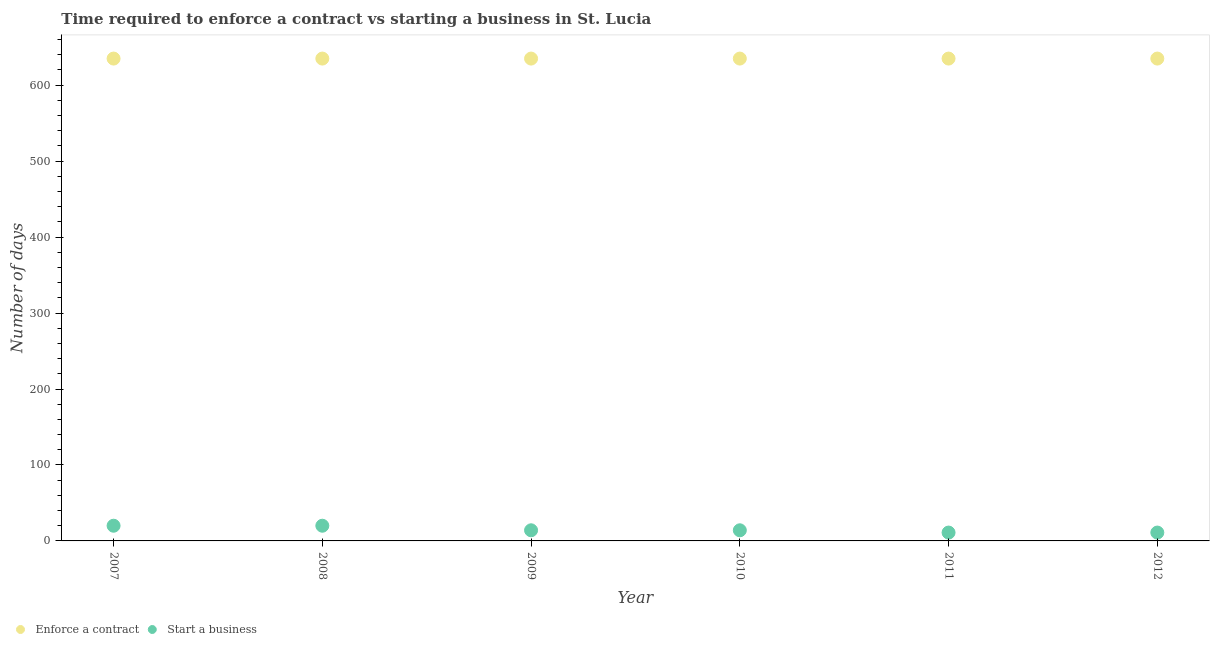How many different coloured dotlines are there?
Make the answer very short. 2. What is the number of days to enforece a contract in 2007?
Provide a succinct answer. 635. Across all years, what is the maximum number of days to start a business?
Ensure brevity in your answer.  20. Across all years, what is the minimum number of days to start a business?
Your answer should be compact. 11. In which year was the number of days to enforece a contract maximum?
Your answer should be compact. 2007. In which year was the number of days to start a business minimum?
Offer a terse response. 2011. What is the total number of days to enforece a contract in the graph?
Make the answer very short. 3810. What is the difference between the number of days to start a business in 2009 and that in 2010?
Offer a very short reply. 0. What is the difference between the number of days to enforece a contract in 2011 and the number of days to start a business in 2010?
Your answer should be compact. 621. What is the average number of days to enforece a contract per year?
Provide a short and direct response. 635. In the year 2009, what is the difference between the number of days to start a business and number of days to enforece a contract?
Provide a succinct answer. -621. In how many years, is the number of days to enforece a contract greater than 380 days?
Make the answer very short. 6. Is the difference between the number of days to start a business in 2010 and 2011 greater than the difference between the number of days to enforece a contract in 2010 and 2011?
Offer a very short reply. Yes. What is the difference between the highest and the lowest number of days to start a business?
Ensure brevity in your answer.  9. In how many years, is the number of days to enforece a contract greater than the average number of days to enforece a contract taken over all years?
Provide a succinct answer. 0. Is the number of days to enforece a contract strictly greater than the number of days to start a business over the years?
Your answer should be very brief. Yes. Is the number of days to start a business strictly less than the number of days to enforece a contract over the years?
Give a very brief answer. Yes. What is the difference between two consecutive major ticks on the Y-axis?
Ensure brevity in your answer.  100. Are the values on the major ticks of Y-axis written in scientific E-notation?
Ensure brevity in your answer.  No. How are the legend labels stacked?
Your response must be concise. Horizontal. What is the title of the graph?
Provide a short and direct response. Time required to enforce a contract vs starting a business in St. Lucia. What is the label or title of the X-axis?
Provide a succinct answer. Year. What is the label or title of the Y-axis?
Your response must be concise. Number of days. What is the Number of days of Enforce a contract in 2007?
Offer a terse response. 635. What is the Number of days in Start a business in 2007?
Your response must be concise. 20. What is the Number of days in Enforce a contract in 2008?
Your answer should be compact. 635. What is the Number of days in Start a business in 2008?
Provide a short and direct response. 20. What is the Number of days of Enforce a contract in 2009?
Offer a terse response. 635. What is the Number of days of Enforce a contract in 2010?
Ensure brevity in your answer.  635. What is the Number of days in Enforce a contract in 2011?
Keep it short and to the point. 635. What is the Number of days of Enforce a contract in 2012?
Offer a very short reply. 635. Across all years, what is the maximum Number of days in Enforce a contract?
Provide a short and direct response. 635. Across all years, what is the maximum Number of days of Start a business?
Give a very brief answer. 20. Across all years, what is the minimum Number of days of Enforce a contract?
Your answer should be compact. 635. What is the total Number of days in Enforce a contract in the graph?
Offer a very short reply. 3810. What is the difference between the Number of days of Enforce a contract in 2007 and that in 2008?
Keep it short and to the point. 0. What is the difference between the Number of days of Start a business in 2007 and that in 2008?
Your answer should be very brief. 0. What is the difference between the Number of days of Enforce a contract in 2007 and that in 2009?
Offer a terse response. 0. What is the difference between the Number of days of Start a business in 2007 and that in 2009?
Provide a succinct answer. 6. What is the difference between the Number of days in Enforce a contract in 2007 and that in 2012?
Offer a very short reply. 0. What is the difference between the Number of days of Start a business in 2007 and that in 2012?
Your response must be concise. 9. What is the difference between the Number of days in Enforce a contract in 2008 and that in 2009?
Give a very brief answer. 0. What is the difference between the Number of days in Enforce a contract in 2008 and that in 2010?
Your answer should be compact. 0. What is the difference between the Number of days in Start a business in 2008 and that in 2010?
Your answer should be compact. 6. What is the difference between the Number of days of Enforce a contract in 2008 and that in 2011?
Ensure brevity in your answer.  0. What is the difference between the Number of days of Start a business in 2008 and that in 2011?
Offer a terse response. 9. What is the difference between the Number of days of Enforce a contract in 2009 and that in 2010?
Offer a terse response. 0. What is the difference between the Number of days of Start a business in 2009 and that in 2011?
Your answer should be very brief. 3. What is the difference between the Number of days in Start a business in 2009 and that in 2012?
Keep it short and to the point. 3. What is the difference between the Number of days in Start a business in 2010 and that in 2012?
Your answer should be very brief. 3. What is the difference between the Number of days in Start a business in 2011 and that in 2012?
Your answer should be very brief. 0. What is the difference between the Number of days in Enforce a contract in 2007 and the Number of days in Start a business in 2008?
Your response must be concise. 615. What is the difference between the Number of days of Enforce a contract in 2007 and the Number of days of Start a business in 2009?
Keep it short and to the point. 621. What is the difference between the Number of days in Enforce a contract in 2007 and the Number of days in Start a business in 2010?
Offer a very short reply. 621. What is the difference between the Number of days in Enforce a contract in 2007 and the Number of days in Start a business in 2011?
Your response must be concise. 624. What is the difference between the Number of days in Enforce a contract in 2007 and the Number of days in Start a business in 2012?
Offer a terse response. 624. What is the difference between the Number of days of Enforce a contract in 2008 and the Number of days of Start a business in 2009?
Offer a very short reply. 621. What is the difference between the Number of days in Enforce a contract in 2008 and the Number of days in Start a business in 2010?
Offer a terse response. 621. What is the difference between the Number of days of Enforce a contract in 2008 and the Number of days of Start a business in 2011?
Give a very brief answer. 624. What is the difference between the Number of days in Enforce a contract in 2008 and the Number of days in Start a business in 2012?
Keep it short and to the point. 624. What is the difference between the Number of days of Enforce a contract in 2009 and the Number of days of Start a business in 2010?
Give a very brief answer. 621. What is the difference between the Number of days in Enforce a contract in 2009 and the Number of days in Start a business in 2011?
Your response must be concise. 624. What is the difference between the Number of days of Enforce a contract in 2009 and the Number of days of Start a business in 2012?
Offer a very short reply. 624. What is the difference between the Number of days of Enforce a contract in 2010 and the Number of days of Start a business in 2011?
Offer a very short reply. 624. What is the difference between the Number of days in Enforce a contract in 2010 and the Number of days in Start a business in 2012?
Your answer should be compact. 624. What is the difference between the Number of days in Enforce a contract in 2011 and the Number of days in Start a business in 2012?
Offer a very short reply. 624. What is the average Number of days in Enforce a contract per year?
Your response must be concise. 635. In the year 2007, what is the difference between the Number of days of Enforce a contract and Number of days of Start a business?
Your answer should be very brief. 615. In the year 2008, what is the difference between the Number of days of Enforce a contract and Number of days of Start a business?
Your answer should be compact. 615. In the year 2009, what is the difference between the Number of days of Enforce a contract and Number of days of Start a business?
Keep it short and to the point. 621. In the year 2010, what is the difference between the Number of days of Enforce a contract and Number of days of Start a business?
Provide a succinct answer. 621. In the year 2011, what is the difference between the Number of days in Enforce a contract and Number of days in Start a business?
Your response must be concise. 624. In the year 2012, what is the difference between the Number of days in Enforce a contract and Number of days in Start a business?
Give a very brief answer. 624. What is the ratio of the Number of days in Enforce a contract in 2007 to that in 2008?
Your answer should be compact. 1. What is the ratio of the Number of days in Start a business in 2007 to that in 2009?
Keep it short and to the point. 1.43. What is the ratio of the Number of days in Start a business in 2007 to that in 2010?
Give a very brief answer. 1.43. What is the ratio of the Number of days in Enforce a contract in 2007 to that in 2011?
Your response must be concise. 1. What is the ratio of the Number of days of Start a business in 2007 to that in 2011?
Your response must be concise. 1.82. What is the ratio of the Number of days of Start a business in 2007 to that in 2012?
Make the answer very short. 1.82. What is the ratio of the Number of days of Start a business in 2008 to that in 2009?
Make the answer very short. 1.43. What is the ratio of the Number of days of Enforce a contract in 2008 to that in 2010?
Offer a very short reply. 1. What is the ratio of the Number of days of Start a business in 2008 to that in 2010?
Make the answer very short. 1.43. What is the ratio of the Number of days in Enforce a contract in 2008 to that in 2011?
Make the answer very short. 1. What is the ratio of the Number of days in Start a business in 2008 to that in 2011?
Provide a short and direct response. 1.82. What is the ratio of the Number of days in Start a business in 2008 to that in 2012?
Keep it short and to the point. 1.82. What is the ratio of the Number of days in Enforce a contract in 2009 to that in 2010?
Provide a short and direct response. 1. What is the ratio of the Number of days of Start a business in 2009 to that in 2011?
Provide a succinct answer. 1.27. What is the ratio of the Number of days in Start a business in 2009 to that in 2012?
Your response must be concise. 1.27. What is the ratio of the Number of days of Start a business in 2010 to that in 2011?
Provide a short and direct response. 1.27. What is the ratio of the Number of days in Enforce a contract in 2010 to that in 2012?
Your answer should be compact. 1. What is the ratio of the Number of days of Start a business in 2010 to that in 2012?
Provide a short and direct response. 1.27. What is the ratio of the Number of days in Start a business in 2011 to that in 2012?
Provide a succinct answer. 1. What is the difference between the highest and the second highest Number of days in Enforce a contract?
Make the answer very short. 0. What is the difference between the highest and the second highest Number of days of Start a business?
Offer a very short reply. 0. 